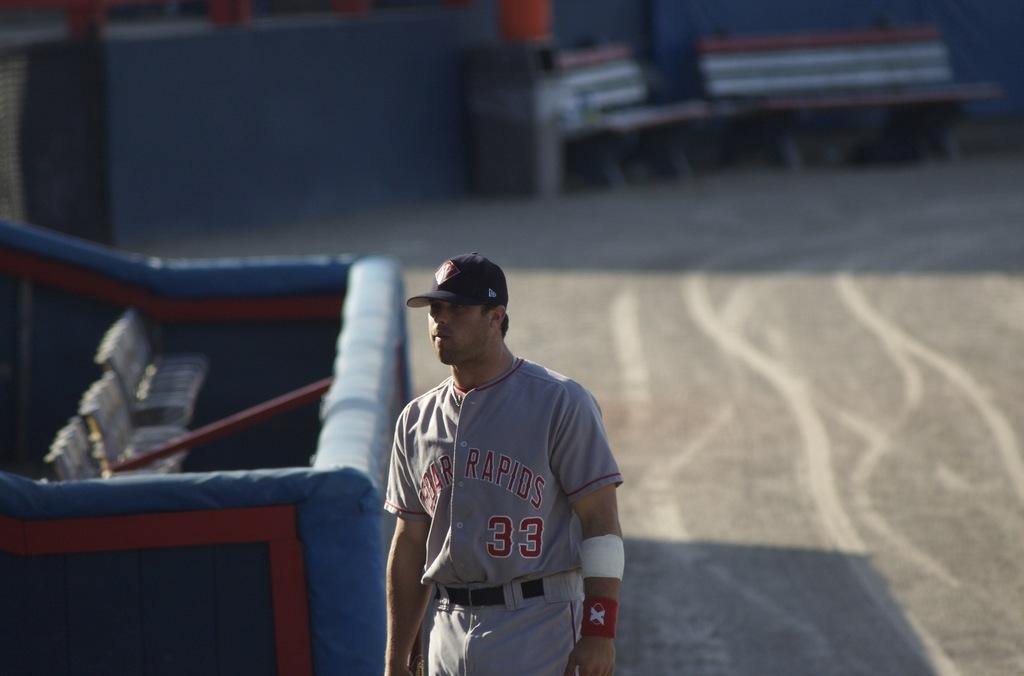What place is mentioned on the front of the person's jersey?
Offer a terse response. Cedar rapids. What number is on his jersey?
Your answer should be very brief. 33. 